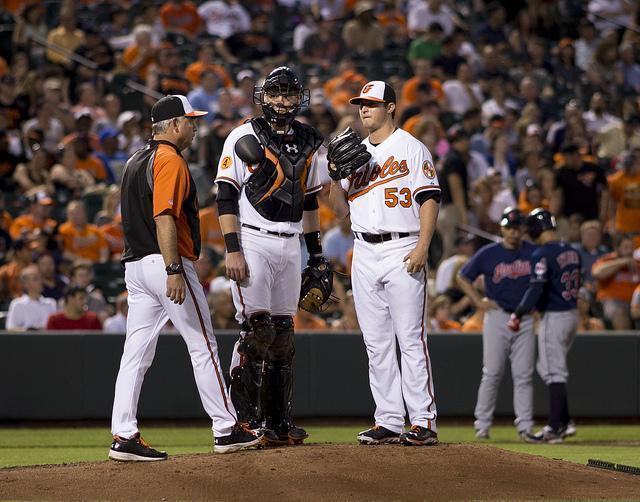How many people are there?
Give a very brief answer. 9. 